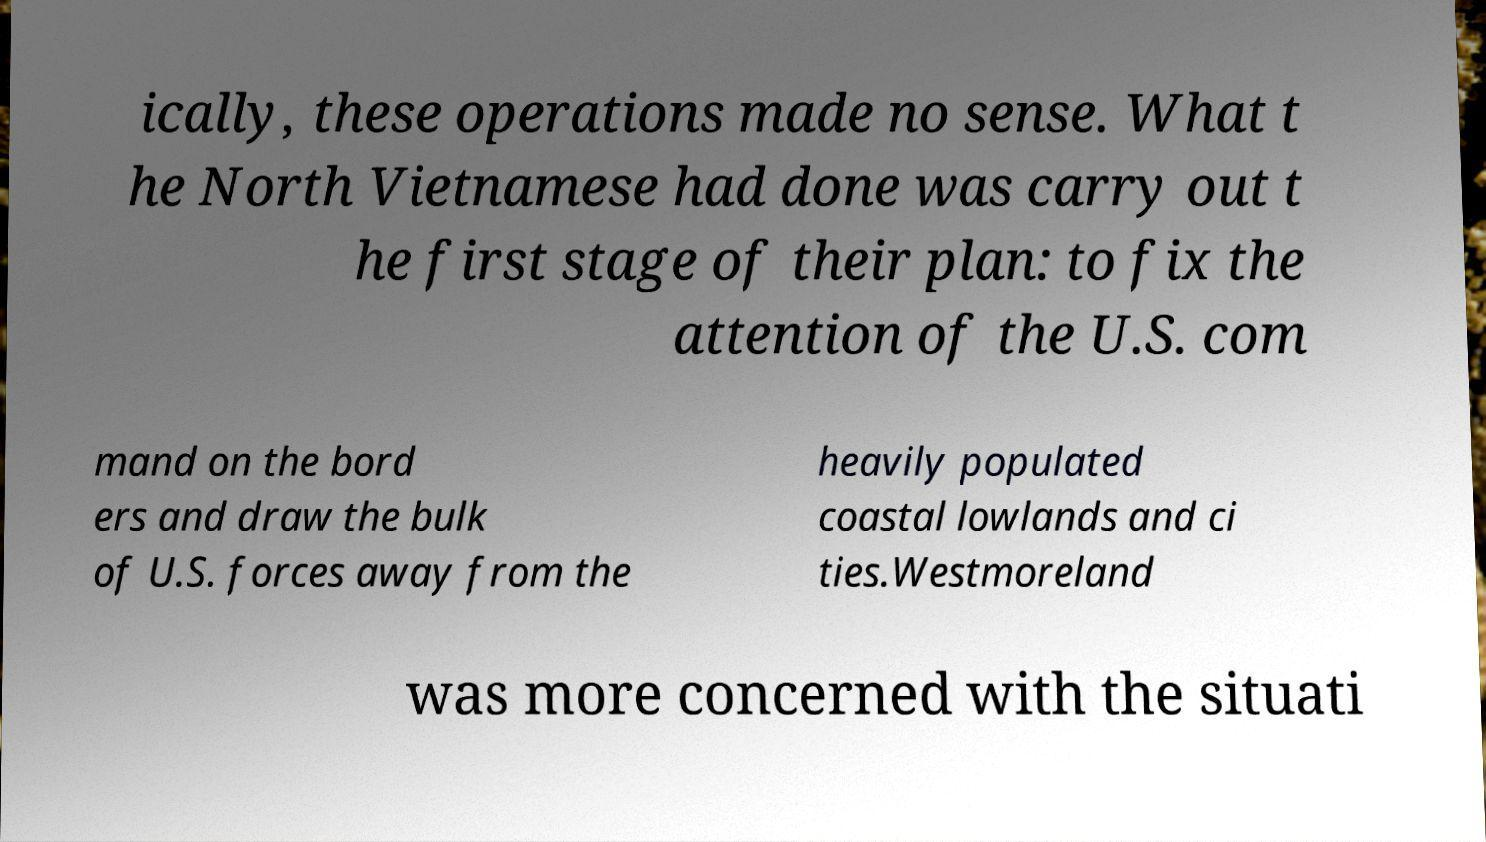Can you accurately transcribe the text from the provided image for me? ically, these operations made no sense. What t he North Vietnamese had done was carry out t he first stage of their plan: to fix the attention of the U.S. com mand on the bord ers and draw the bulk of U.S. forces away from the heavily populated coastal lowlands and ci ties.Westmoreland was more concerned with the situati 